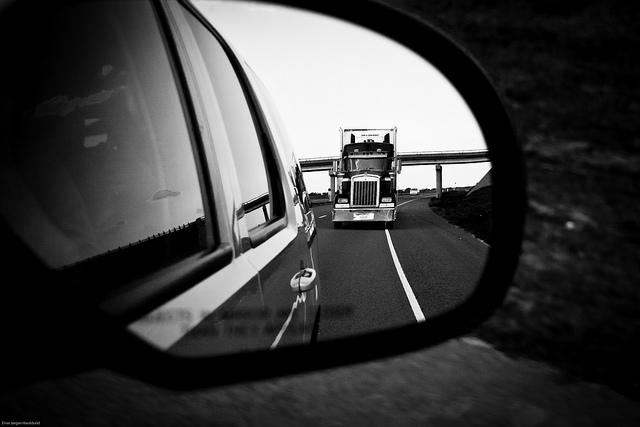Is it a car or truck in the mirror?
Concise answer only. Truck. What shape is the mirror?
Answer briefly. Oval. What is on the mirror?
Write a very short answer. Truck. Who would ride on the vehicle in the mirror?
Be succinct. Truck driver. What type of truck is in the mirror?
Keep it brief. Semi. 